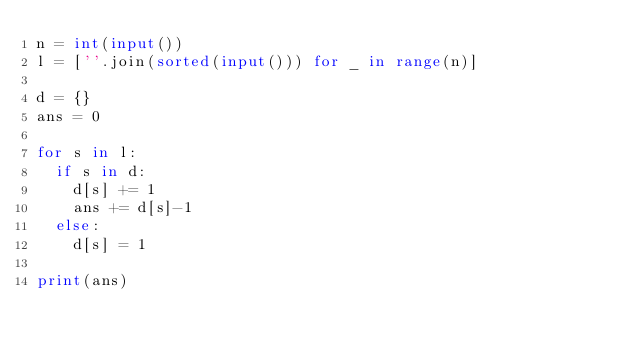<code> <loc_0><loc_0><loc_500><loc_500><_Python_>n = int(input())
l = [''.join(sorted(input())) for _ in range(n)]

d = {}
ans = 0

for s in l:
  if s in d:
    d[s] += 1
    ans += d[s]-1
  else:
    d[s] = 1

print(ans)</code> 